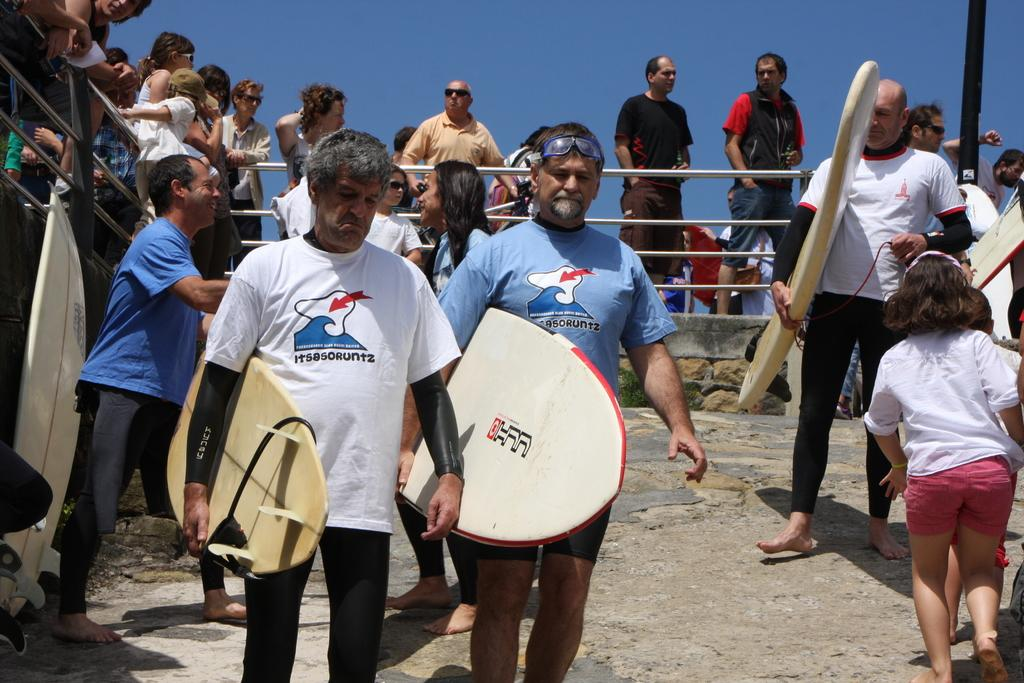What can be seen in the background of the image? There is a clear blue sky in the background of the image. What is the main subject of the image? There is a crowd in the image. What are the persons in the crowd holding? The persons holding surfboards are visible in the image. What are the persons holding surfboards doing? The persons holding surfboards are walking. What type of pickle is being used as a surfboard in the image? There is no pickle present in the image, and the surfboards are not made of pickles. 